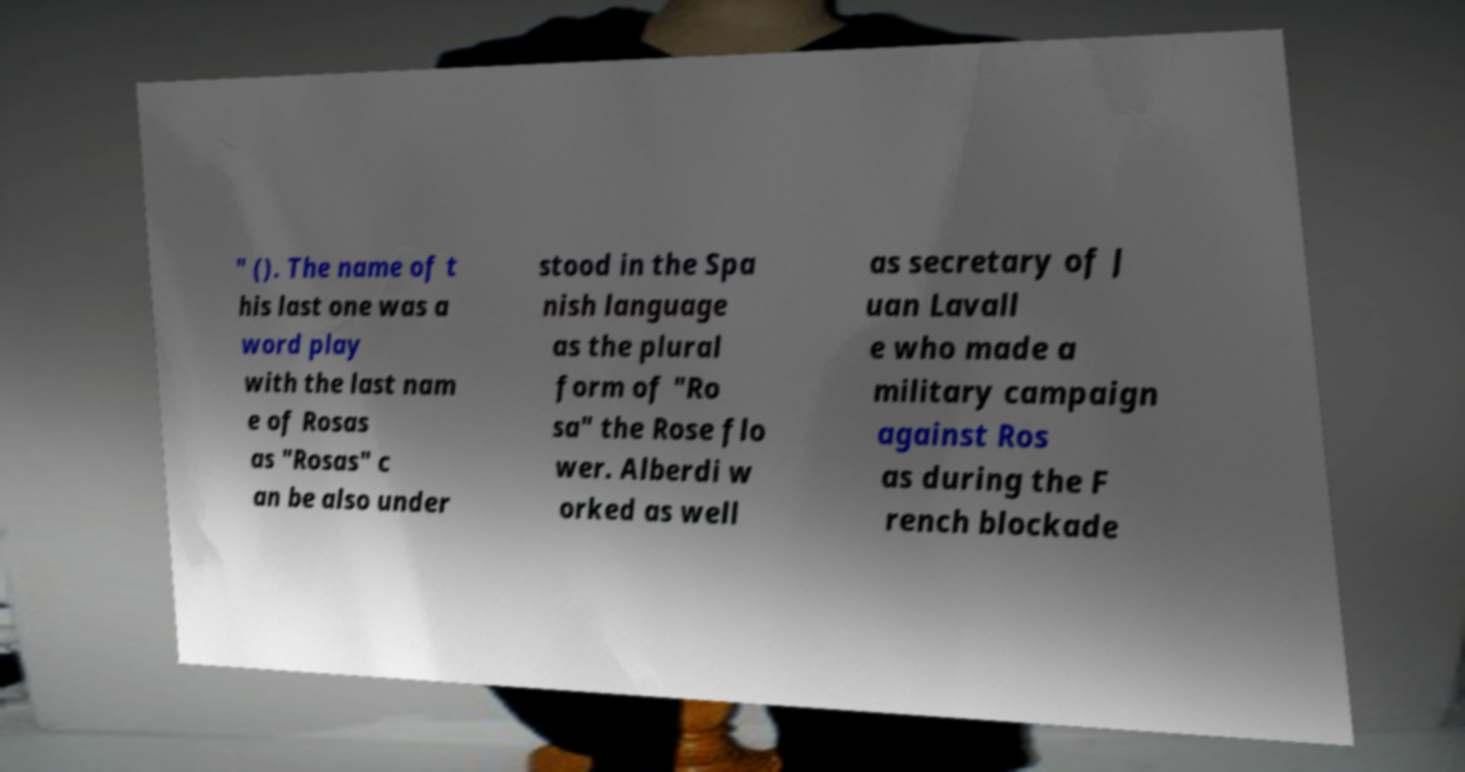What messages or text are displayed in this image? I need them in a readable, typed format. " (). The name of t his last one was a word play with the last nam e of Rosas as "Rosas" c an be also under stood in the Spa nish language as the plural form of "Ro sa" the Rose flo wer. Alberdi w orked as well as secretary of J uan Lavall e who made a military campaign against Ros as during the F rench blockade 